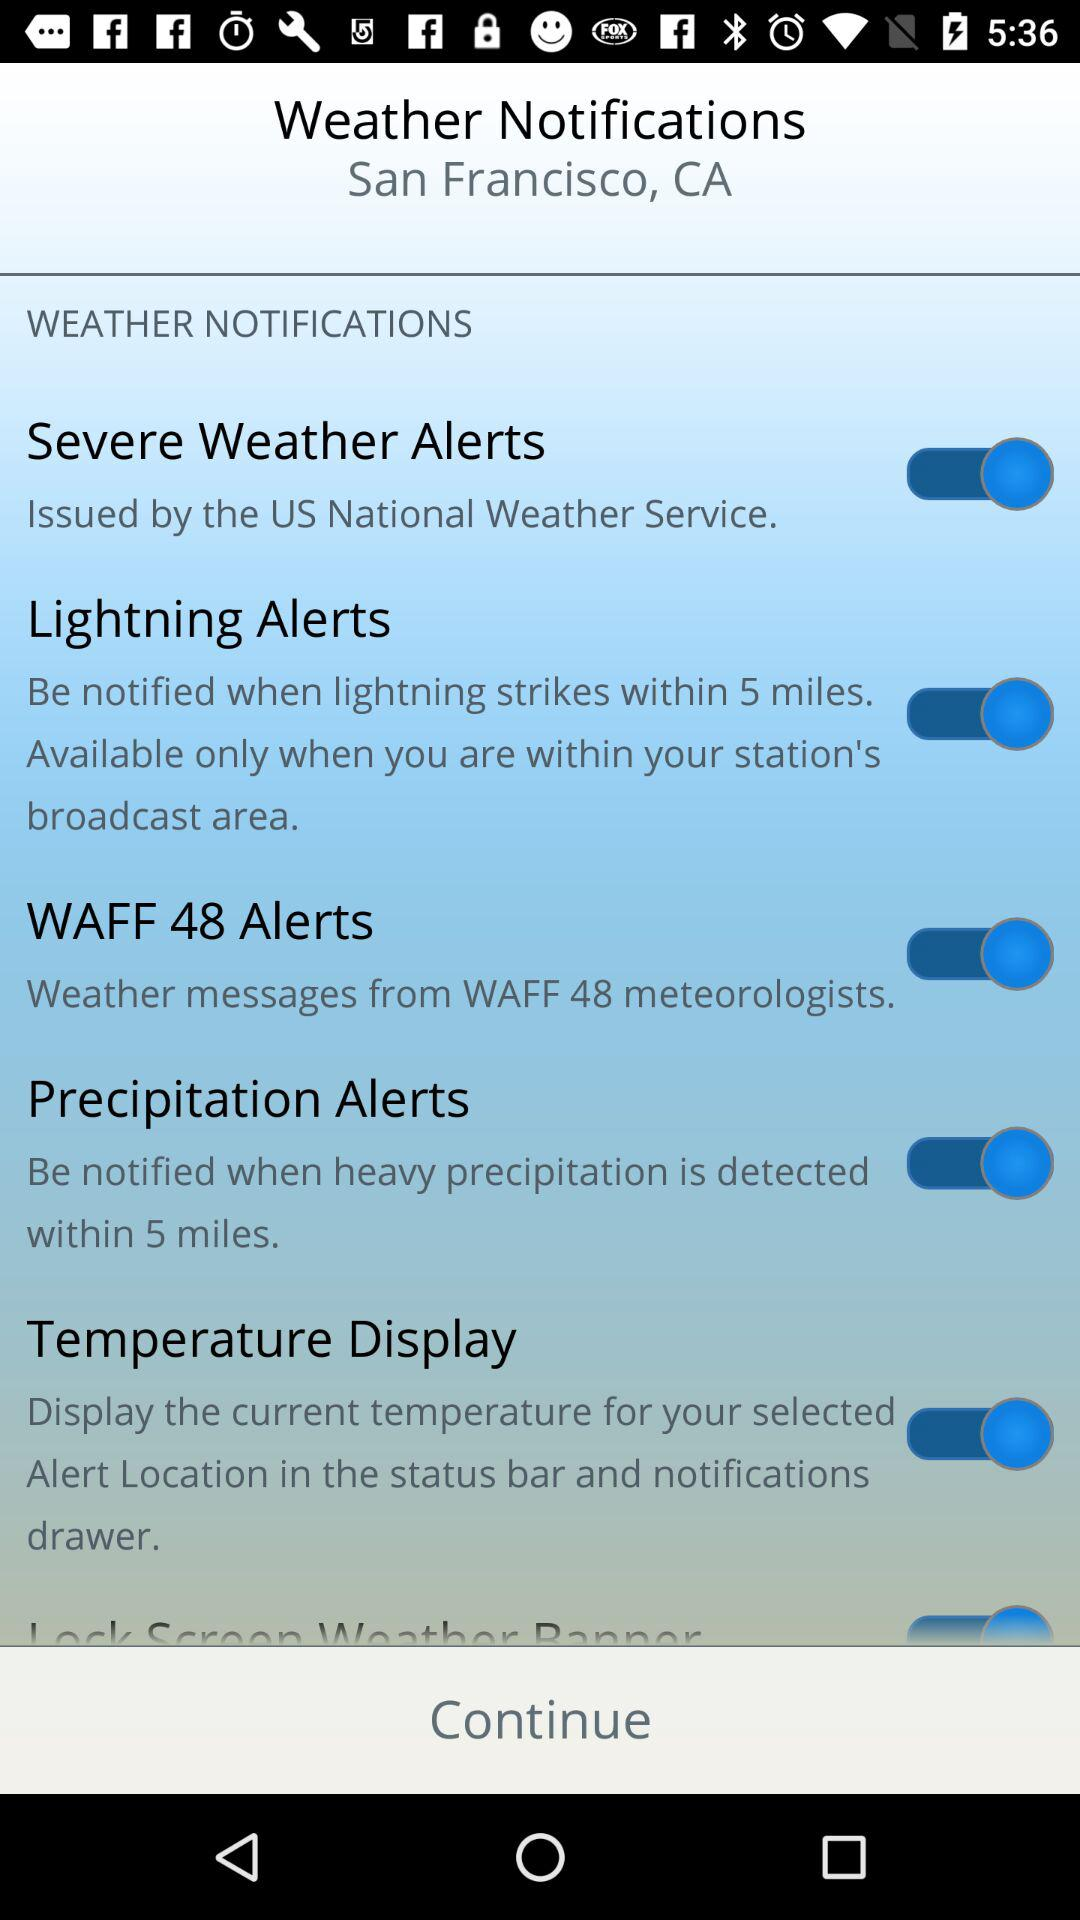What is the status of "WAFF 48 Alerts"? The status of "WAFF 48 Alerts" is "on". 